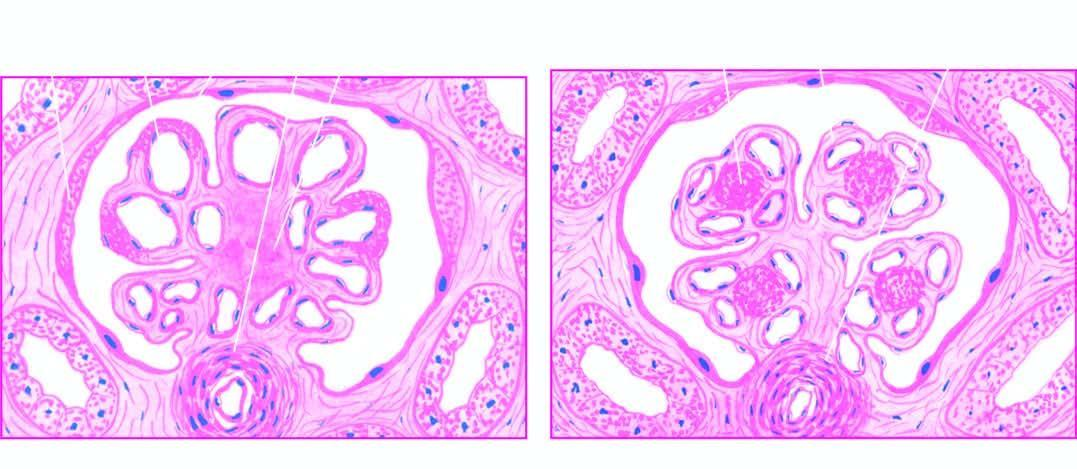re there one or more hyaline nodules within the lobules of glomeruli, surrounded peripherally by glomerular capillaries with thickened walls?
Answer the question using a single word or phrase. Yes 